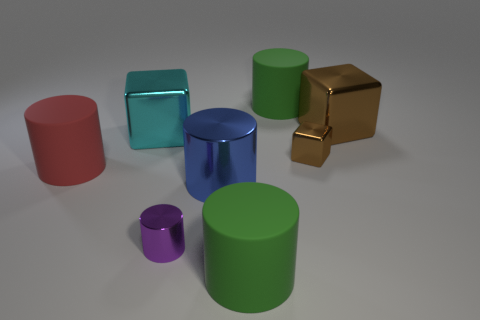Imagine these objects are part of a learning toy for children, how could it be used educationally? These vibrant geometric objects could serve as excellent educational tools for young learners. By engaging with these items, children could learn about shapes, color recognition, and spatial relationships. For example, a learning activity may be sorting the objects by shape or color, stacking the cubes or cylinders, or even utilizing them to explain concepts such as volume and size comparison, all in a fun and interactive way. 